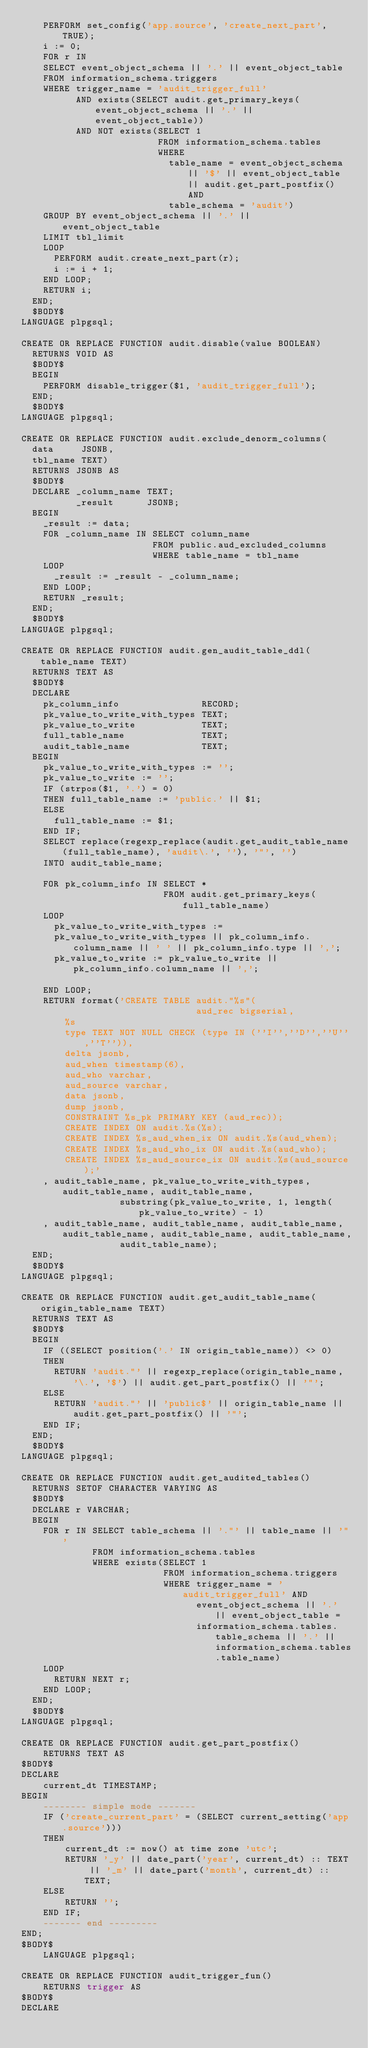<code> <loc_0><loc_0><loc_500><loc_500><_SQL_>    PERFORM set_config('app.source', 'create_next_part', TRUE);
    i := 0;
    FOR r IN
    SELECT event_object_schema || '.' || event_object_table
    FROM information_schema.triggers
    WHERE trigger_name = 'audit_trigger_full'
          AND exists(SELECT audit.get_primary_keys(event_object_schema || '.' || event_object_table))
          AND NOT exists(SELECT 1
                         FROM information_schema.tables
                         WHERE
                           table_name = event_object_schema || '$' || event_object_table || audit.get_part_postfix() AND
                           table_schema = 'audit')
    GROUP BY event_object_schema || '.' || event_object_table
    LIMIT tbl_limit
    LOOP
      PERFORM audit.create_next_part(r);
      i := i + 1;
    END LOOP;
    RETURN i;
  END;
  $BODY$
LANGUAGE plpgsql;

CREATE OR REPLACE FUNCTION audit.disable(value BOOLEAN)
  RETURNS VOID AS
  $BODY$
  BEGIN
    PERFORM disable_trigger($1, 'audit_trigger_full');
  END;
  $BODY$
LANGUAGE plpgsql;

CREATE OR REPLACE FUNCTION audit.exclude_denorm_columns(
  data     JSONB,
  tbl_name TEXT)
  RETURNS JSONB AS
  $BODY$
  DECLARE _column_name TEXT;
          _result      JSONB;
  BEGIN
    _result := data;
    FOR _column_name IN SELECT column_name
                        FROM public.aud_excluded_columns
                        WHERE table_name = tbl_name
    LOOP
      _result := _result - _column_name;
    END LOOP;
    RETURN _result;
  END;
  $BODY$
LANGUAGE plpgsql;

CREATE OR REPLACE FUNCTION audit.gen_audit_table_ddl(table_name TEXT)
  RETURNS TEXT AS
  $BODY$
  DECLARE
    pk_column_info               RECORD;
    pk_value_to_write_with_types TEXT;
    pk_value_to_write            TEXT;
    full_table_name              TEXT;
    audit_table_name             TEXT;
  BEGIN
    pk_value_to_write_with_types := '';
    pk_value_to_write := '';
    IF (strpos($1, '.') = 0)
    THEN full_table_name := 'public.' || $1;
    ELSE
      full_table_name := $1;
    END IF;
    SELECT replace(regexp_replace(audit.get_audit_table_name(full_table_name), 'audit\.', ''), '"', '')
    INTO audit_table_name;

    FOR pk_column_info IN SELECT *
                          FROM audit.get_primary_keys(full_table_name)
    LOOP
      pk_value_to_write_with_types :=
      pk_value_to_write_with_types || pk_column_info.column_name || ' ' || pk_column_info.type || ',';
      pk_value_to_write := pk_value_to_write || pk_column_info.column_name || ',';

    END LOOP;
    RETURN format('CREATE TABLE audit."%s"(
                                aud_rec bigserial,
				%s
				type TEXT NOT NULL CHECK (type IN (''I'',''D'',''U'',''T'')),
				delta jsonb,
				aud_when timestamp(6),
				aud_who varchar,
				aud_source varchar,
				data jsonb,
				dump jsonb,
				CONSTRAINT %s_pk PRIMARY KEY (aud_rec));
				CREATE INDEX ON audit.%s(%s);
				CREATE INDEX %s_aud_when_ix ON audit.%s(aud_when);
				CREATE INDEX %s_aud_who_ix ON audit.%s(aud_who);
				CREATE INDEX %s_aud_source_ix ON audit.%s(aud_source);'
    , audit_table_name, pk_value_to_write_with_types, audit_table_name, audit_table_name,
                  substring(pk_value_to_write, 1, length(pk_value_to_write) - 1)
    , audit_table_name, audit_table_name, audit_table_name, audit_table_name, audit_table_name, audit_table_name,
                  audit_table_name);
  END;
  $BODY$
LANGUAGE plpgsql;

CREATE OR REPLACE FUNCTION audit.get_audit_table_name(origin_table_name TEXT)
  RETURNS TEXT AS
  $BODY$
  BEGIN
    IF ((SELECT position('.' IN origin_table_name)) <> 0)
    THEN
      RETURN 'audit."' || regexp_replace(origin_table_name, '\.', '$') || audit.get_part_postfix() || '"';
    ELSE
      RETURN 'audit."' || 'public$' || origin_table_name || audit.get_part_postfix() || '"';
    END IF;
  END;
  $BODY$
LANGUAGE plpgsql;

CREATE OR REPLACE FUNCTION audit.get_audited_tables()
  RETURNS SETOF CHARACTER VARYING AS
  $BODY$
  DECLARE r VARCHAR;
  BEGIN
    FOR r IN SELECT table_schema || '."' || table_name || '"'
             FROM information_schema.tables
             WHERE exists(SELECT 1
                          FROM information_schema.triggers
                          WHERE trigger_name = 'audit_trigger_full' AND
                                event_object_schema || '.' || event_object_table =
                                information_schema.tables.table_schema || '.' || information_schema.tables.table_name)
    LOOP
      RETURN NEXT r;
    END LOOP;
  END;
  $BODY$
LANGUAGE plpgsql;

CREATE OR REPLACE FUNCTION audit.get_part_postfix()
    RETURNS TEXT AS
$BODY$
DECLARE
    current_dt TIMESTAMP;
BEGIN
    -------- simple mode -------
    IF ('create_current_part' = (SELECT current_setting('app.source')))
    THEN
        current_dt := now() at time zone 'utc';
        RETURN '_y' || date_part('year', current_dt) :: TEXT || '_m' || date_part('month', current_dt) :: TEXT;
    ELSE
        RETURN '';
    END IF;
    ------- end ---------
END;
$BODY$
    LANGUAGE plpgsql;

CREATE OR REPLACE FUNCTION audit_trigger_fun()
    RETURNS trigger AS
$BODY$
DECLARE</code> 